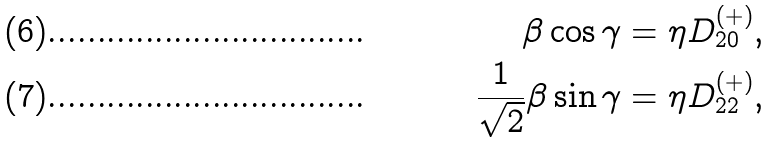<formula> <loc_0><loc_0><loc_500><loc_500>\beta \cos \gamma & = \eta D ^ { ( + ) } _ { 2 0 } , \\ \frac { 1 } { \sqrt { 2 } } \beta \sin \gamma & = \eta D ^ { ( + ) } _ { 2 2 } ,</formula> 